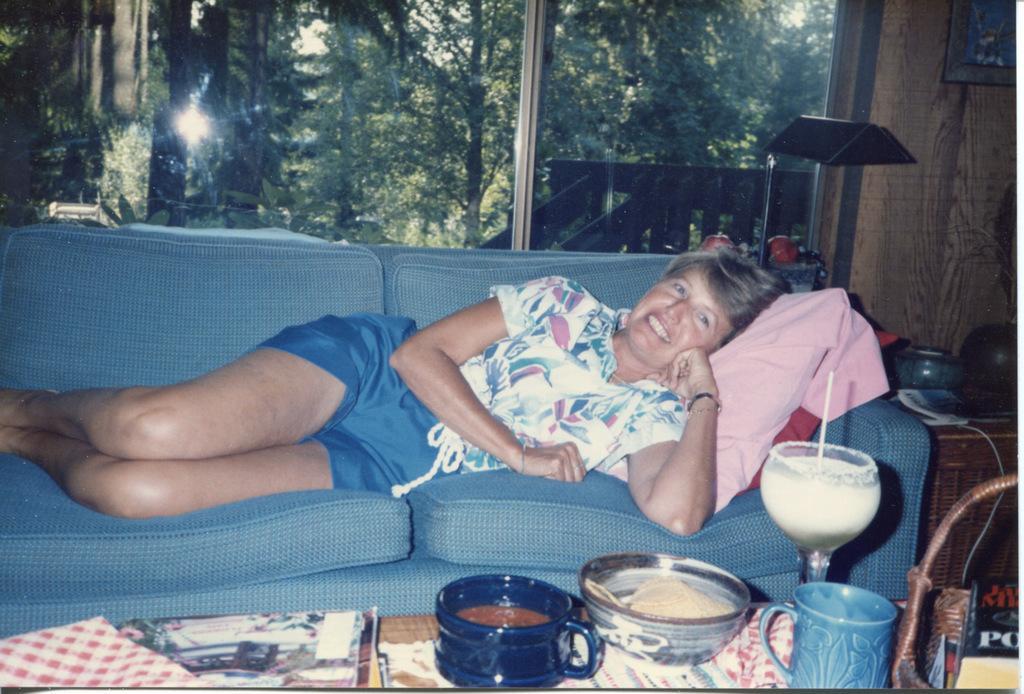Could you give a brief overview of what you see in this image? In the picture we can see a woman sleeping on the sofa and smiling, before the sofa we can see a table, on the table we can find a cloth, books, cup which is blue in color, and a bowl, and glass with some drink and straw in it. In the background we can see a glass window, from that we can see trees. 